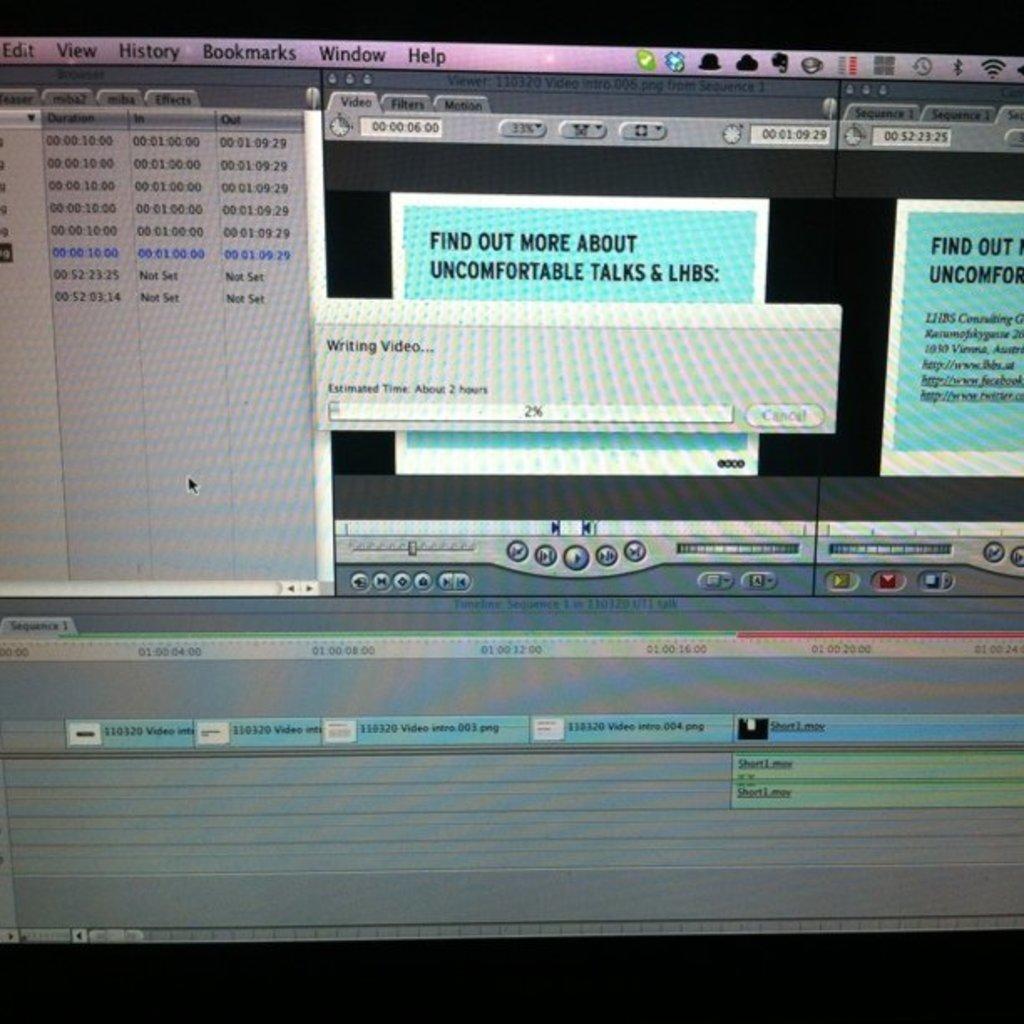How far along is the writing video percentage?
Offer a terse response. 2%. 